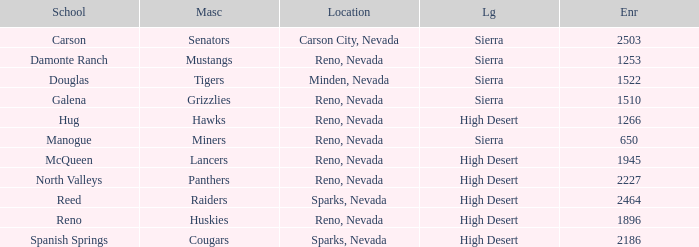Which leagues have Raiders as their mascot? High Desert. 